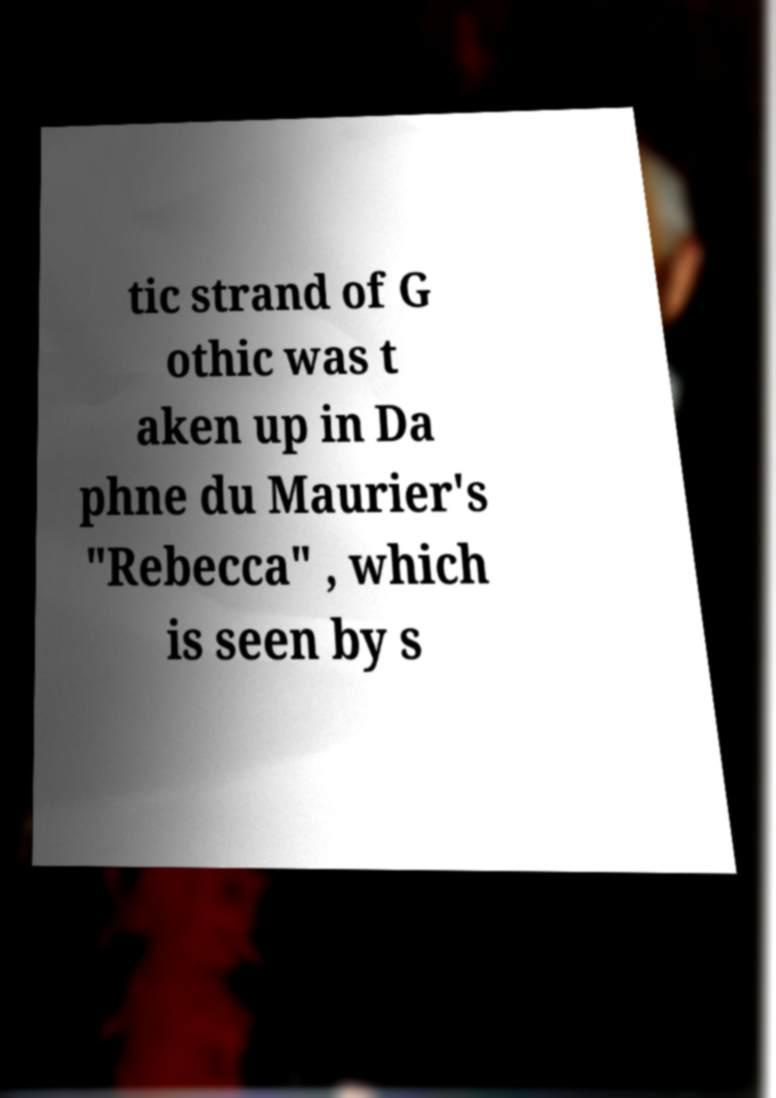What messages or text are displayed in this image? I need them in a readable, typed format. tic strand of G othic was t aken up in Da phne du Maurier's "Rebecca" , which is seen by s 